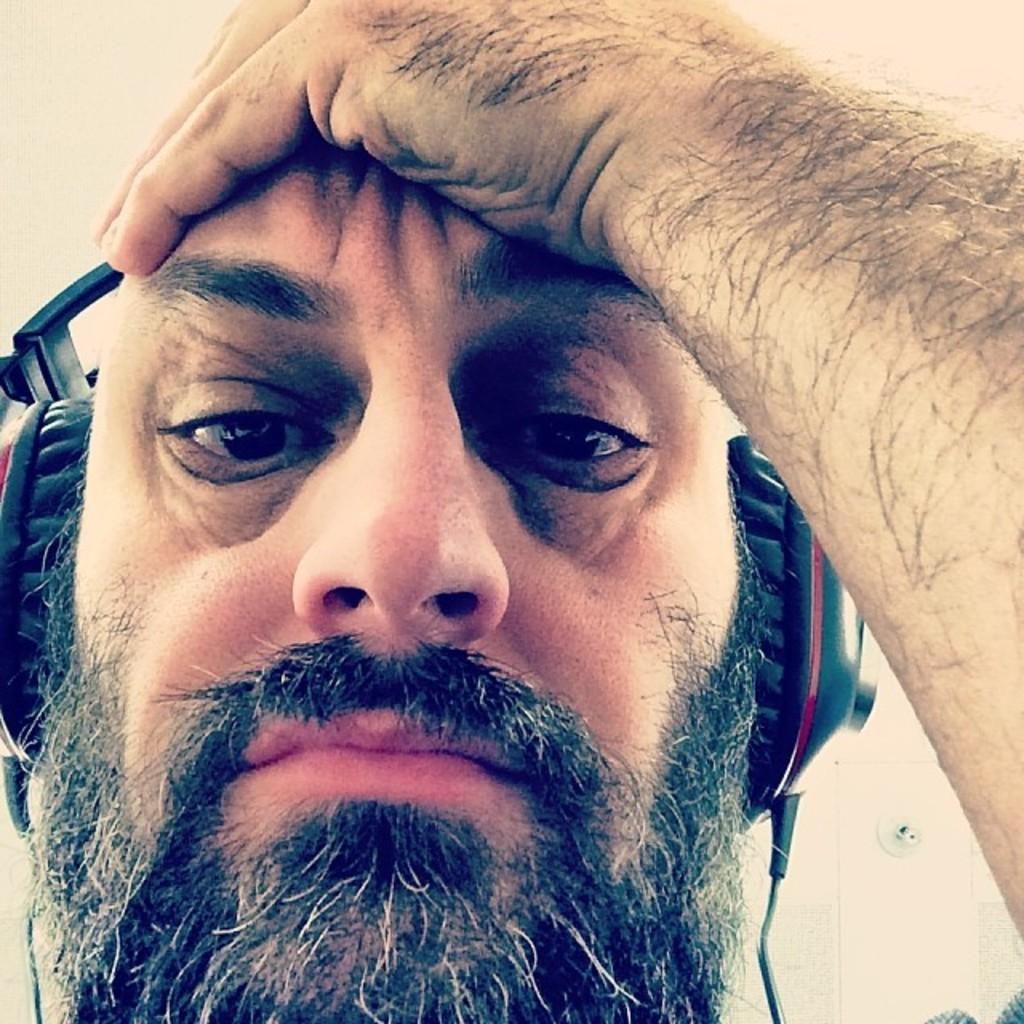In one or two sentences, can you explain what this image depicts? In this picture I can see a man's face and I see that he is wearing a headphone. 